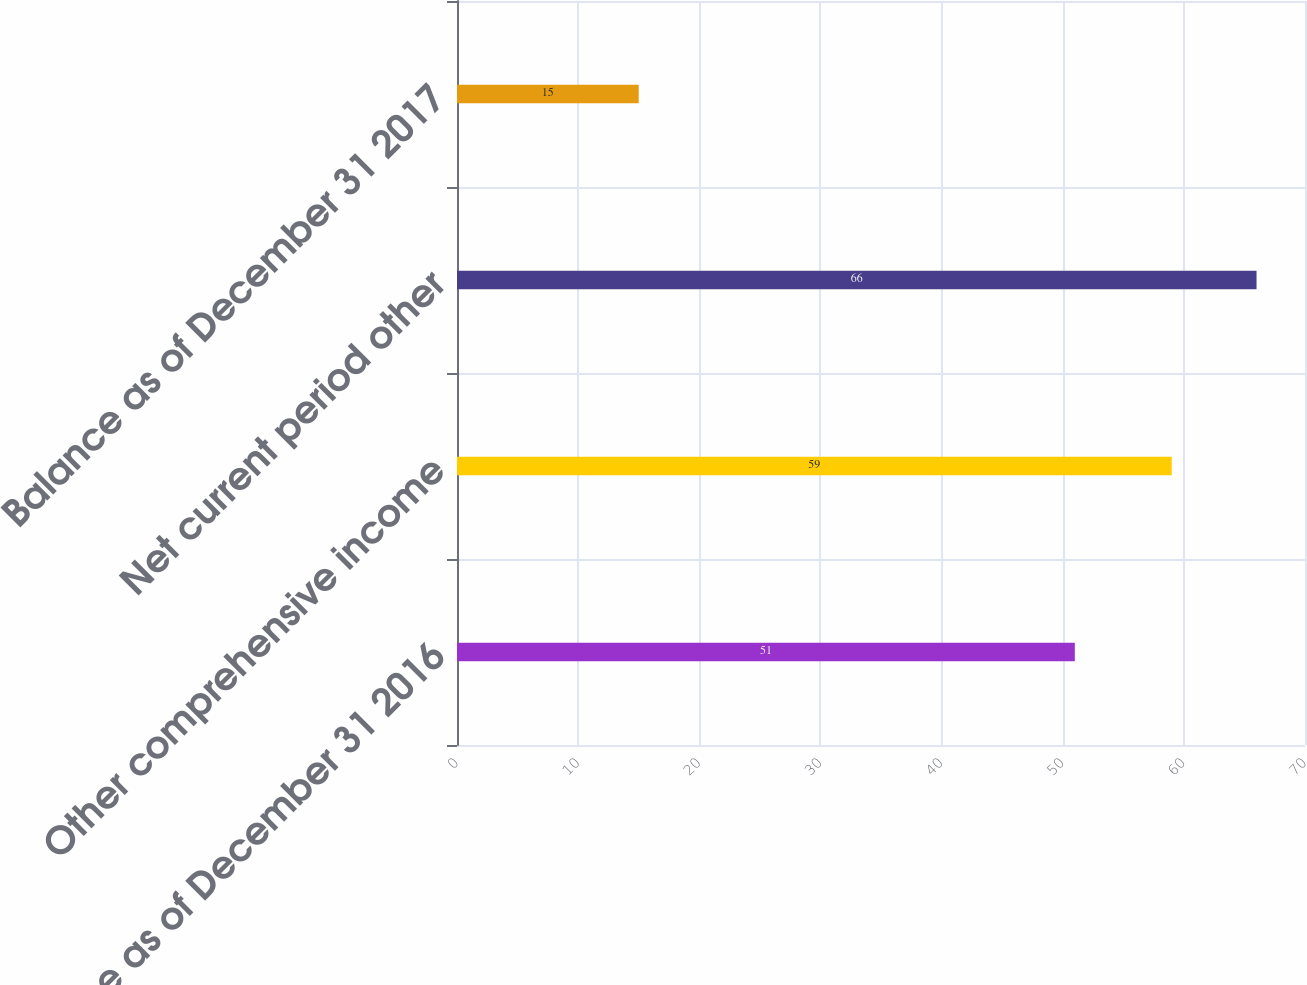<chart> <loc_0><loc_0><loc_500><loc_500><bar_chart><fcel>Balance as of December 31 2016<fcel>Other comprehensive income<fcel>Net current period other<fcel>Balance as of December 31 2017<nl><fcel>51<fcel>59<fcel>66<fcel>15<nl></chart> 